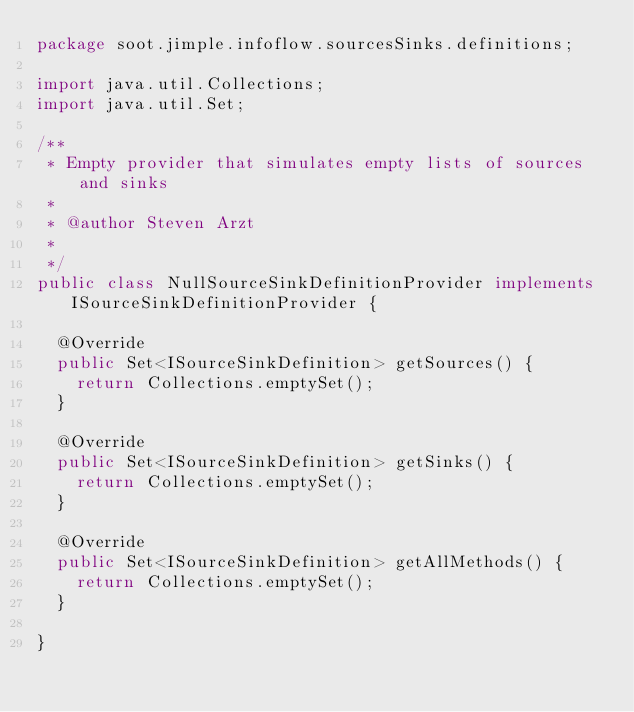<code> <loc_0><loc_0><loc_500><loc_500><_Java_>package soot.jimple.infoflow.sourcesSinks.definitions;

import java.util.Collections;
import java.util.Set;

/**
 * Empty provider that simulates empty lists of sources and sinks
 * 
 * @author Steven Arzt
 *
 */
public class NullSourceSinkDefinitionProvider implements ISourceSinkDefinitionProvider {

	@Override
	public Set<ISourceSinkDefinition> getSources() {
		return Collections.emptySet();
	}

	@Override
	public Set<ISourceSinkDefinition> getSinks() {
		return Collections.emptySet();
	}

	@Override
	public Set<ISourceSinkDefinition> getAllMethods() {
		return Collections.emptySet();
	}

}
</code> 